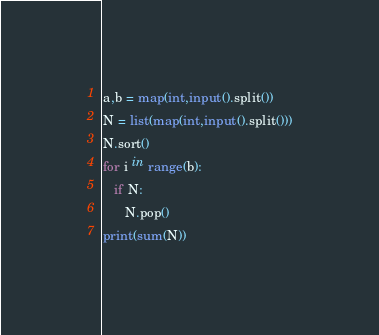<code> <loc_0><loc_0><loc_500><loc_500><_Python_>a,b = map(int,input().split())
N = list(map(int,input().split()))
N.sort()
for i in range(b):
   if N:
      N.pop()
print(sum(N))</code> 